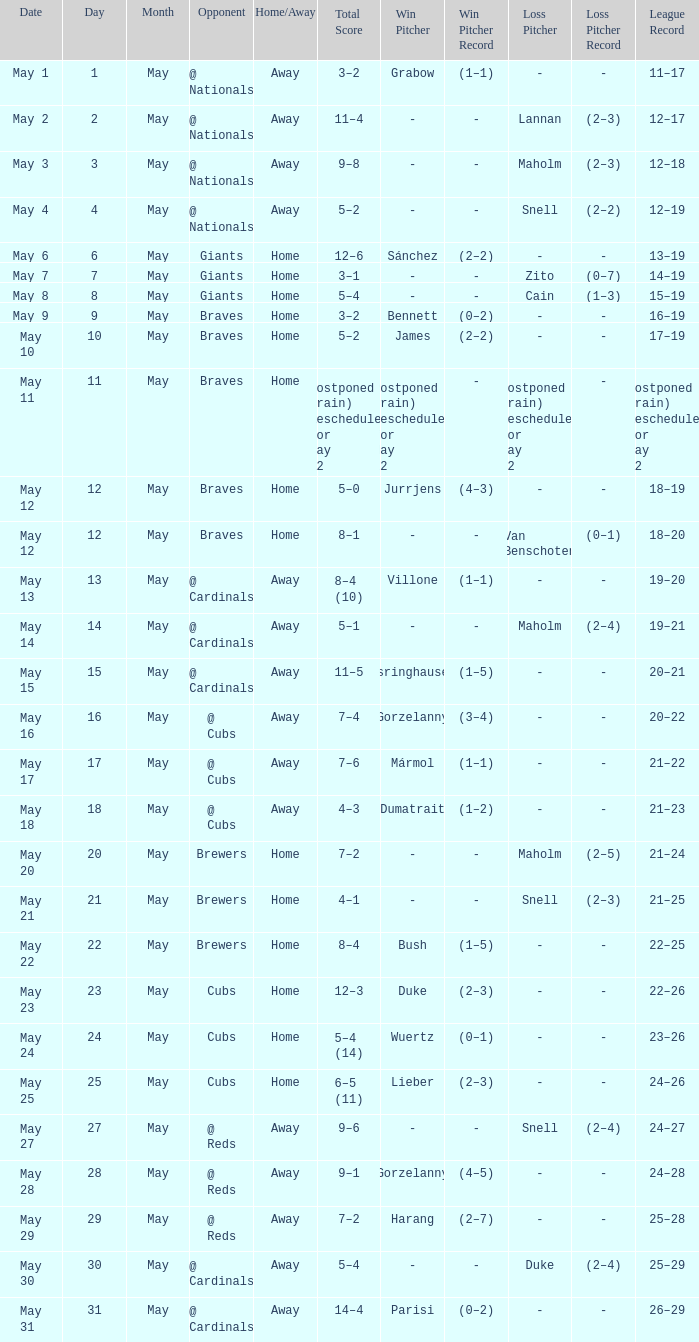What was the record of the game with a score of 12–6? 13–19. 